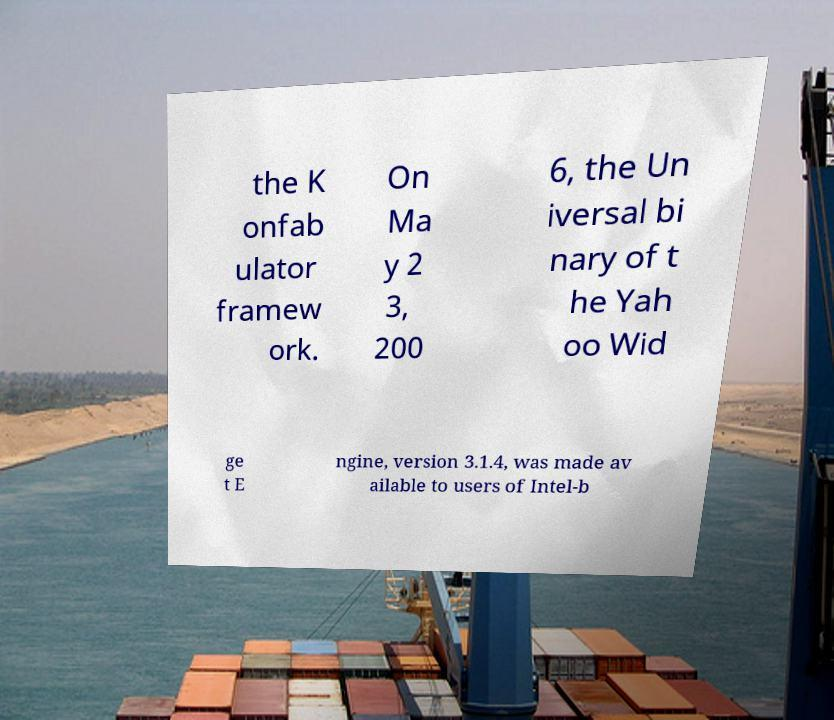Please identify and transcribe the text found in this image. the K onfab ulator framew ork. On Ma y 2 3, 200 6, the Un iversal bi nary of t he Yah oo Wid ge t E ngine, version 3.1.4, was made av ailable to users of Intel-b 